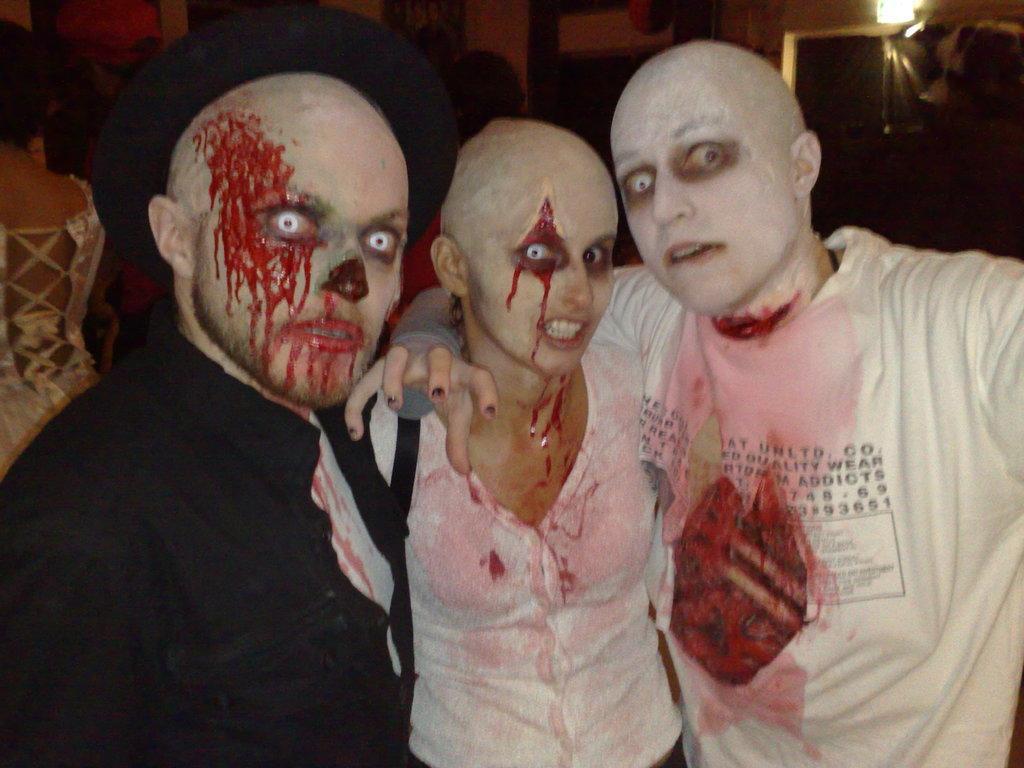Can you describe this image briefly? In the image there are people with hallowed makeups and costumes 